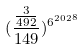Convert formula to latex. <formula><loc_0><loc_0><loc_500><loc_500>( \frac { \frac { 3 } { 4 9 2 } } { 1 4 9 } ) ^ { { 6 ^ { 2 0 2 } } ^ { 8 } }</formula> 